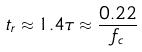Convert formula to latex. <formula><loc_0><loc_0><loc_500><loc_500>t _ { r } \approx 1 . 4 \tau \approx \frac { 0 . 2 2 } { f _ { c } }</formula> 